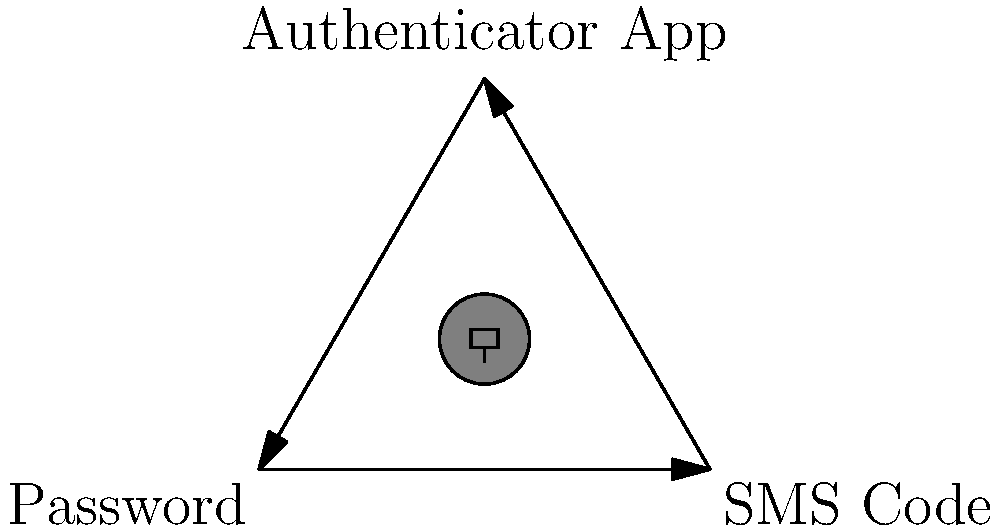In the diagram above, which two-factor authentication method is considered the most secure and why? To answer this question, let's analyze the three methods shown in the diagram:

1. Password: This is the most basic form of authentication and is typically considered the first factor.

2. SMS Code: This is a common second factor, where a code is sent to the user's phone via text message.

3. Authenticator App: This method generates time-based one-time passwords (TOTP) on the user's device.

Now, let's compare their security:

1. Passwords can be compromised through various means like phishing, keylogging, or data breaches.

2. SMS codes are vulnerable to SIM swapping attacks and interception of text messages.

3. Authenticator apps generate codes locally on the device, making them resistant to interception. They also use time-based algorithms, so the codes expire quickly.

Among these options, the Authenticator App is considered the most secure because:

a) It's not vulnerable to SMS interception or SIM swapping.
b) The codes are generated locally, reducing the risk of man-in-the-middle attacks.
c) The codes change frequently (usually every 30 seconds), making them more resistant to replay attacks.
d) It doesn't rely on network connectivity to receive codes, unlike SMS.

For a web designer interested in internet security, understanding these differences is crucial for implementing robust authentication systems and advising clients on best practices.
Answer: Authenticator App 